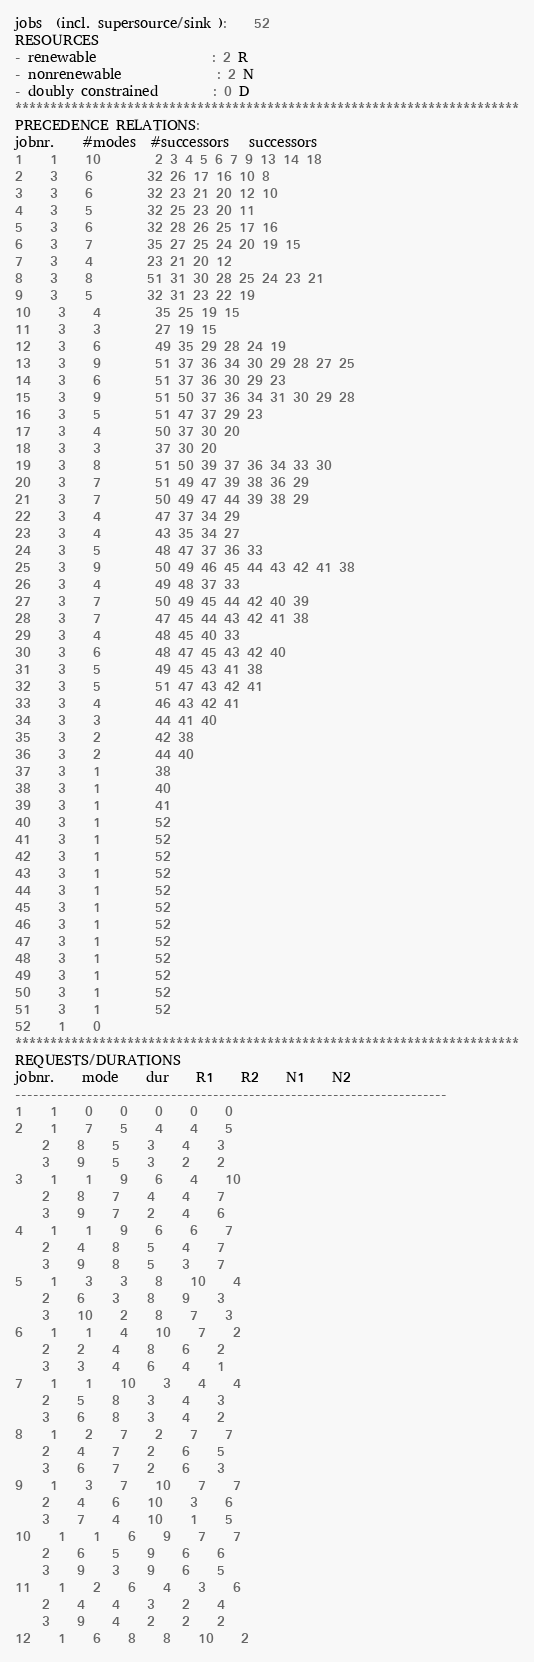<code> <loc_0><loc_0><loc_500><loc_500><_ObjectiveC_>jobs  (incl. supersource/sink ):	52
RESOURCES
- renewable                 : 2 R
- nonrenewable              : 2 N
- doubly constrained        : 0 D
************************************************************************
PRECEDENCE RELATIONS:
jobnr.    #modes  #successors   successors
1	1	10		2 3 4 5 6 7 9 13 14 18 
2	3	6		32 26 17 16 10 8 
3	3	6		32 23 21 20 12 10 
4	3	5		32 25 23 20 11 
5	3	6		32 28 26 25 17 16 
6	3	7		35 27 25 24 20 19 15 
7	3	4		23 21 20 12 
8	3	8		51 31 30 28 25 24 23 21 
9	3	5		32 31 23 22 19 
10	3	4		35 25 19 15 
11	3	3		27 19 15 
12	3	6		49 35 29 28 24 19 
13	3	9		51 37 36 34 30 29 28 27 25 
14	3	6		51 37 36 30 29 23 
15	3	9		51 50 37 36 34 31 30 29 28 
16	3	5		51 47 37 29 23 
17	3	4		50 37 30 20 
18	3	3		37 30 20 
19	3	8		51 50 39 37 36 34 33 30 
20	3	7		51 49 47 39 38 36 29 
21	3	7		50 49 47 44 39 38 29 
22	3	4		47 37 34 29 
23	3	4		43 35 34 27 
24	3	5		48 47 37 36 33 
25	3	9		50 49 46 45 44 43 42 41 38 
26	3	4		49 48 37 33 
27	3	7		50 49 45 44 42 40 39 
28	3	7		47 45 44 43 42 41 38 
29	3	4		48 45 40 33 
30	3	6		48 47 45 43 42 40 
31	3	5		49 45 43 41 38 
32	3	5		51 47 43 42 41 
33	3	4		46 43 42 41 
34	3	3		44 41 40 
35	3	2		42 38 
36	3	2		44 40 
37	3	1		38 
38	3	1		40 
39	3	1		41 
40	3	1		52 
41	3	1		52 
42	3	1		52 
43	3	1		52 
44	3	1		52 
45	3	1		52 
46	3	1		52 
47	3	1		52 
48	3	1		52 
49	3	1		52 
50	3	1		52 
51	3	1		52 
52	1	0		
************************************************************************
REQUESTS/DURATIONS
jobnr.	mode	dur	R1	R2	N1	N2	
------------------------------------------------------------------------
1	1	0	0	0	0	0	
2	1	7	5	4	4	5	
	2	8	5	3	4	3	
	3	9	5	3	2	2	
3	1	1	9	6	4	10	
	2	8	7	4	4	7	
	3	9	7	2	4	6	
4	1	1	9	6	6	7	
	2	4	8	5	4	7	
	3	9	8	5	3	7	
5	1	3	3	8	10	4	
	2	6	3	8	9	3	
	3	10	2	8	7	3	
6	1	1	4	10	7	2	
	2	2	4	8	6	2	
	3	3	4	6	4	1	
7	1	1	10	3	4	4	
	2	5	8	3	4	3	
	3	6	8	3	4	2	
8	1	2	7	2	7	7	
	2	4	7	2	6	5	
	3	6	7	2	6	3	
9	1	3	7	10	7	7	
	2	4	6	10	3	6	
	3	7	4	10	1	5	
10	1	1	6	9	7	7	
	2	6	5	9	6	6	
	3	9	3	9	6	5	
11	1	2	6	4	3	6	
	2	4	4	3	2	4	
	3	9	4	2	2	2	
12	1	6	8	8	10	2	</code> 